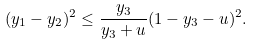<formula> <loc_0><loc_0><loc_500><loc_500>( y _ { 1 } - y _ { 2 } ) ^ { 2 } \leq \frac { y _ { 3 } } { y _ { 3 } + u } ( 1 - y _ { 3 } - u ) ^ { 2 } .</formula> 